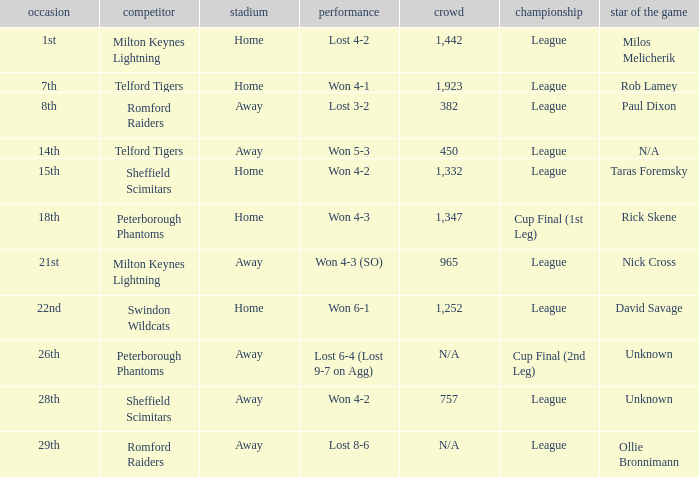On what date was the venue Away and the result was lost 6-4 (lost 9-7 on agg)? 26th. 